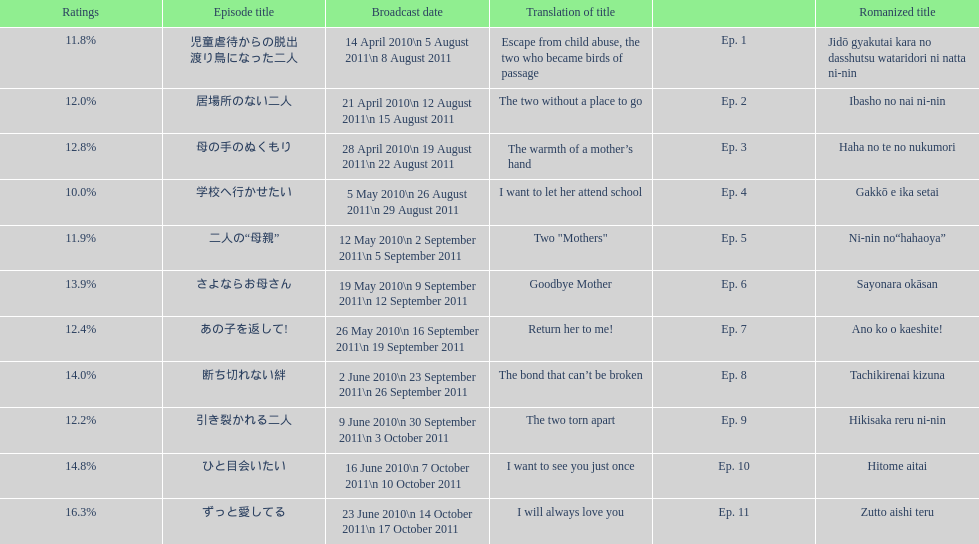How many episodes had a consecutive rating over 11%? 7. 